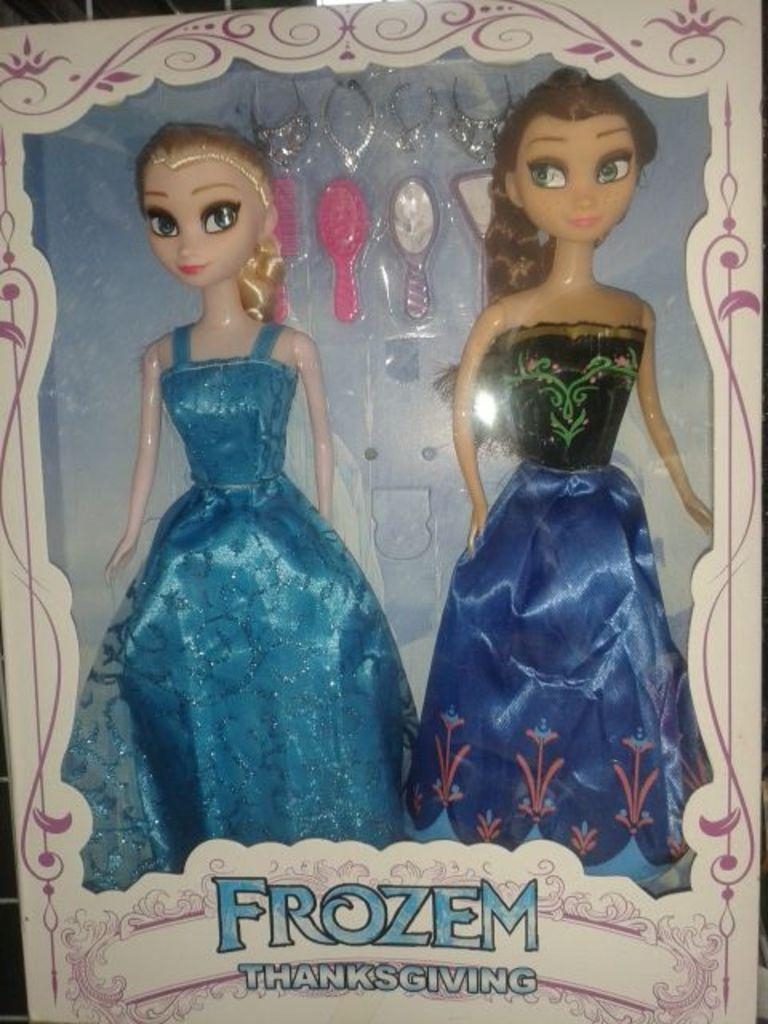What type of objects can be seen in the image? There are dolls in the image. Can you describe any specific details about the dolls? There is text written on the cover of at least one doll. Is there a river visible in the image? No, there is no river present in the image. What type of bait is being used by the dolls in the image? There are no dolls using bait in the image, as dolls are inanimate objects and do not engage in such activities. 